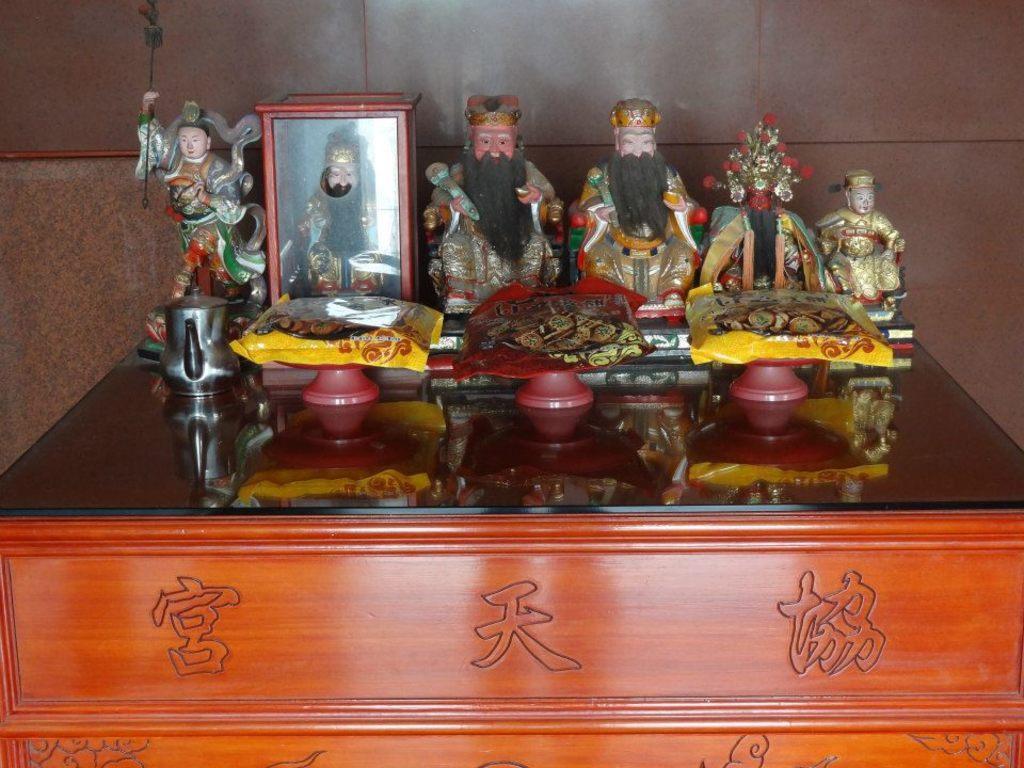Can you describe this image briefly? In the image we can see there is a table on which there are statue of persons kept on the table and there are bowls and packet of boxes. 